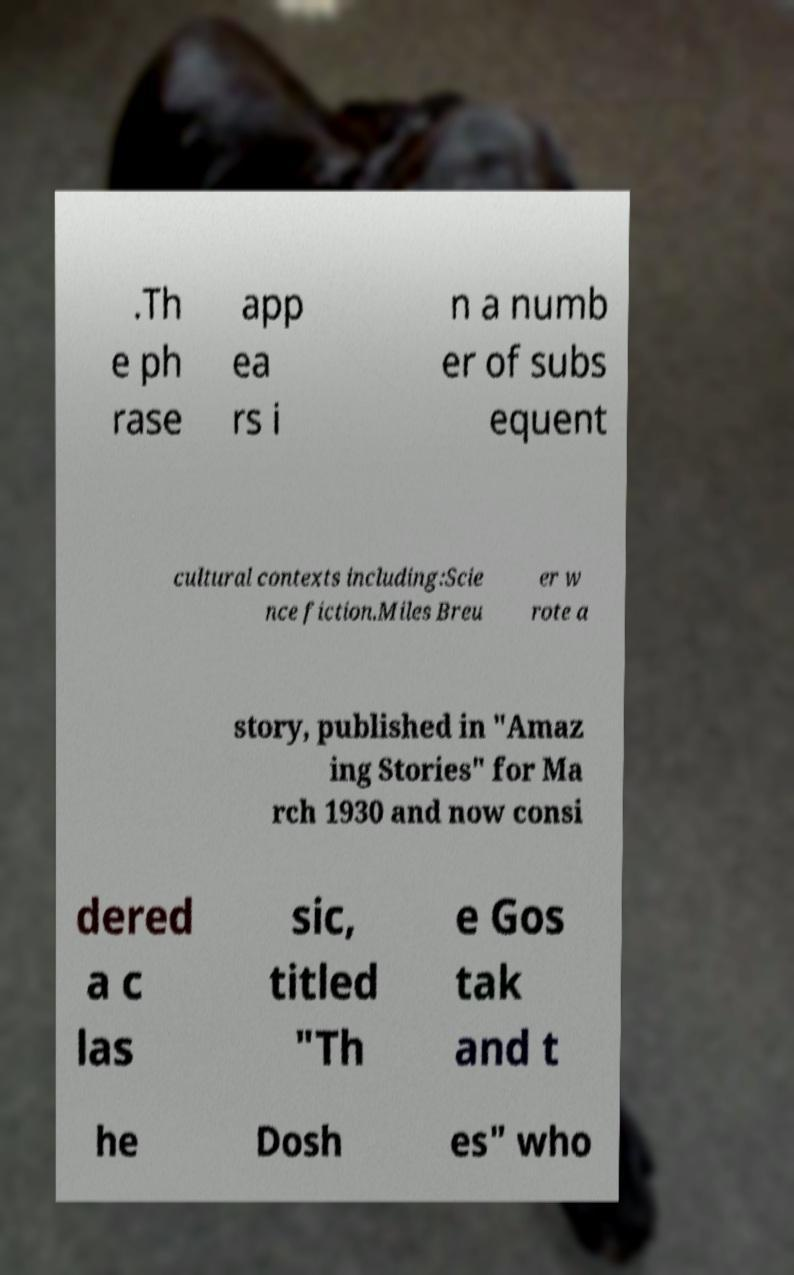There's text embedded in this image that I need extracted. Can you transcribe it verbatim? .Th e ph rase app ea rs i n a numb er of subs equent cultural contexts including:Scie nce fiction.Miles Breu er w rote a story, published in "Amaz ing Stories" for Ma rch 1930 and now consi dered a c las sic, titled "Th e Gos tak and t he Dosh es" who 